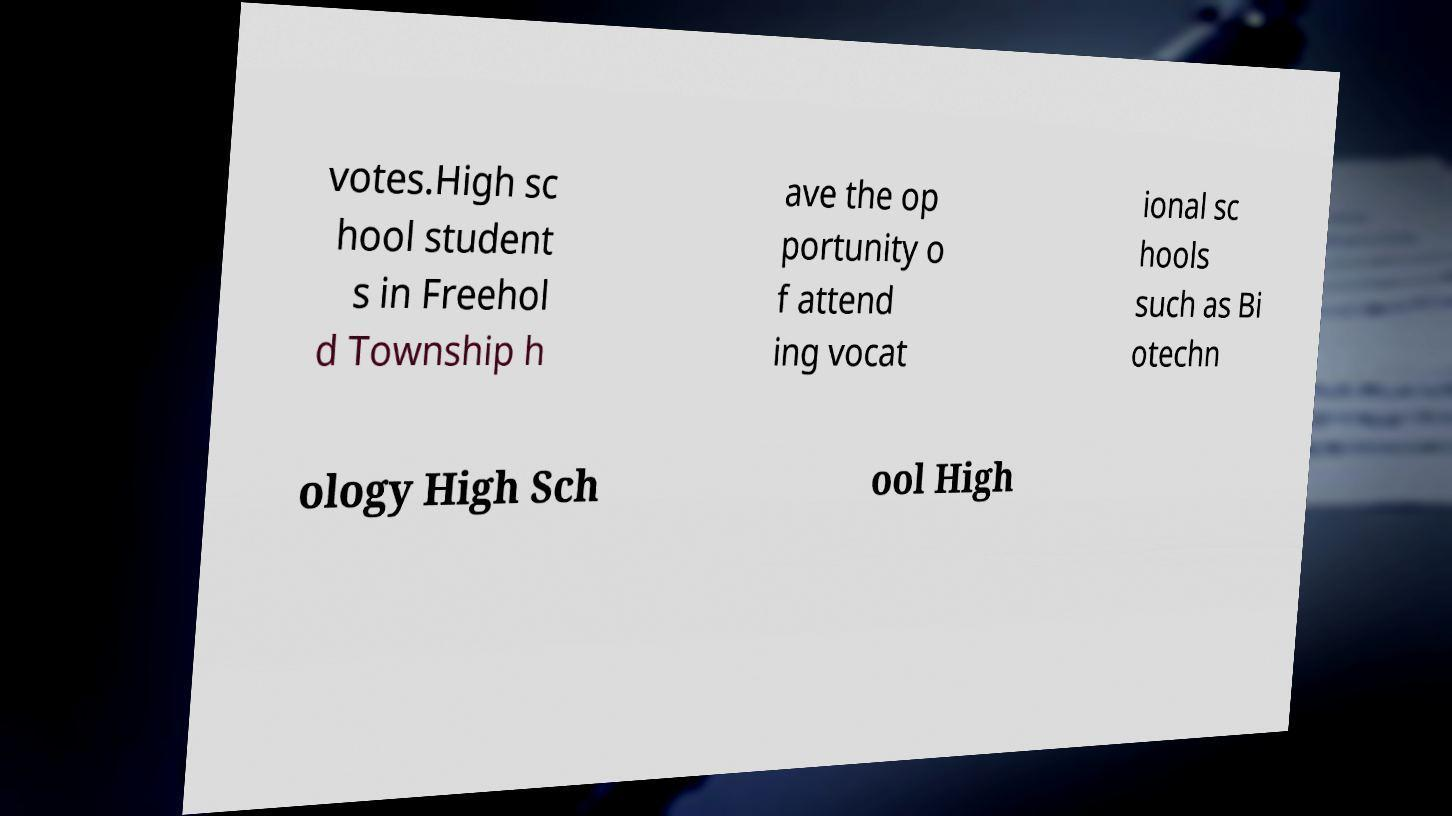Please read and relay the text visible in this image. What does it say? votes.High sc hool student s in Freehol d Township h ave the op portunity o f attend ing vocat ional sc hools such as Bi otechn ology High Sch ool High 